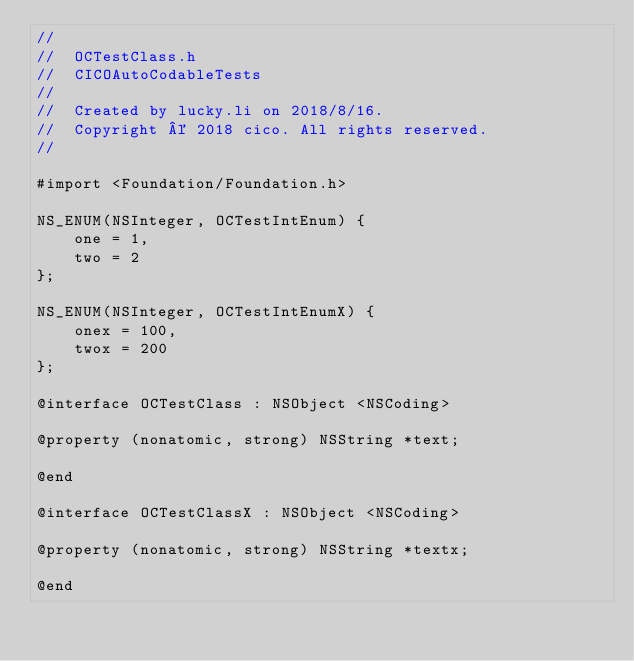<code> <loc_0><loc_0><loc_500><loc_500><_C_>//
//  OCTestClass.h
//  CICOAutoCodableTests
//
//  Created by lucky.li on 2018/8/16.
//  Copyright © 2018 cico. All rights reserved.
//

#import <Foundation/Foundation.h>

NS_ENUM(NSInteger, OCTestIntEnum) {
    one = 1,
    two = 2
};

NS_ENUM(NSInteger, OCTestIntEnumX) {
    onex = 100,
    twox = 200
};

@interface OCTestClass : NSObject <NSCoding>

@property (nonatomic, strong) NSString *text;

@end

@interface OCTestClassX : NSObject <NSCoding>

@property (nonatomic, strong) NSString *textx;

@end
</code> 